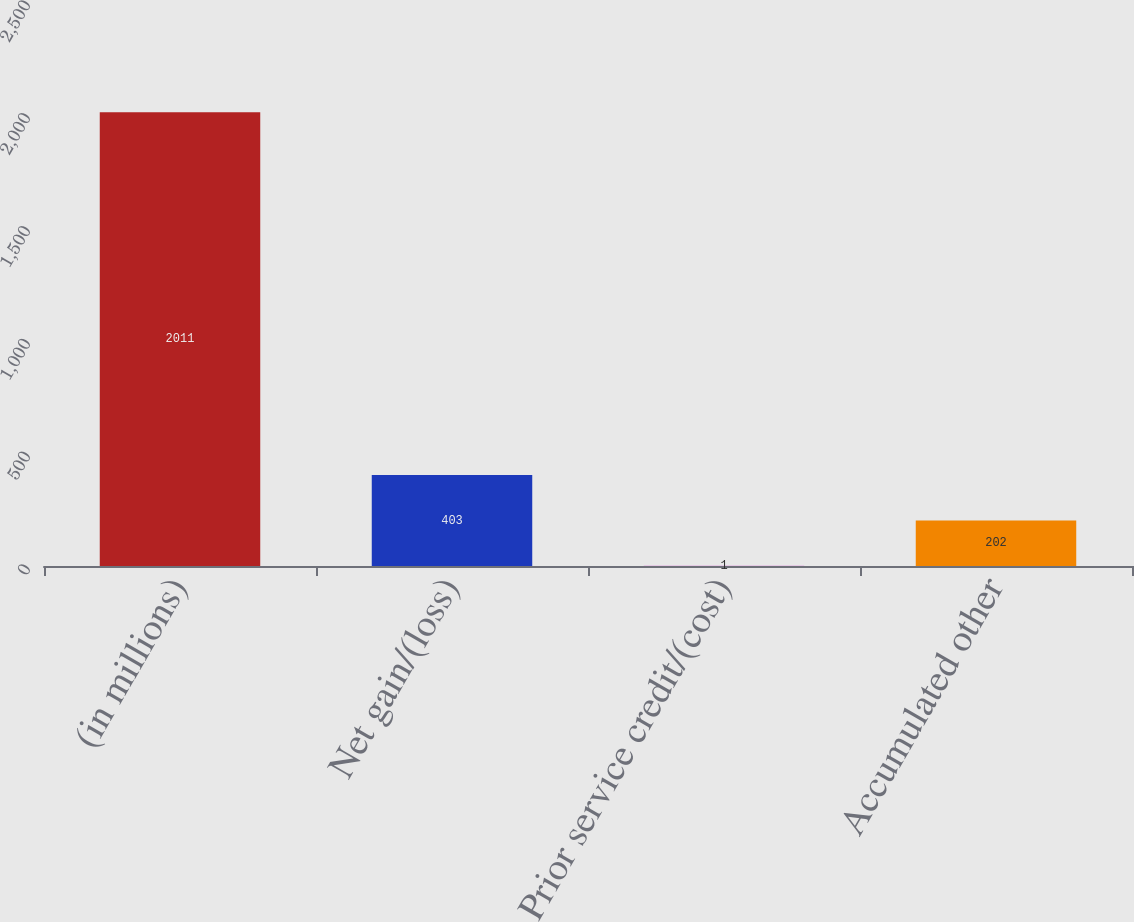Convert chart. <chart><loc_0><loc_0><loc_500><loc_500><bar_chart><fcel>(in millions)<fcel>Net gain/(loss)<fcel>Prior service credit/(cost)<fcel>Accumulated other<nl><fcel>2011<fcel>403<fcel>1<fcel>202<nl></chart> 